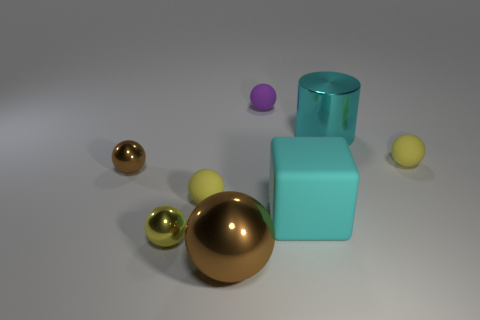There is a large metallic thing that is the same color as the rubber cube; what shape is it?
Give a very brief answer. Cylinder. What number of balls are purple rubber objects or cyan metal objects?
Your response must be concise. 1. Is the material of the tiny ball that is on the right side of the purple rubber object the same as the big brown ball?
Provide a succinct answer. No. What number of other things are the same size as the cyan metallic cylinder?
Ensure brevity in your answer.  2. How many tiny things are green things or yellow metal spheres?
Your answer should be very brief. 1. Is the color of the large cylinder the same as the matte block?
Provide a succinct answer. Yes. Is the number of rubber balls that are left of the big brown metallic sphere greater than the number of big cubes to the left of the small yellow metal sphere?
Offer a very short reply. Yes. There is a tiny metal sphere that is to the left of the tiny yellow shiny object; is it the same color as the big ball?
Provide a short and direct response. Yes. Is the number of large objects that are in front of the big cyan matte cube greater than the number of small cyan rubber things?
Make the answer very short. Yes. Does the yellow shiny thing have the same size as the cyan matte cube?
Provide a short and direct response. No. 